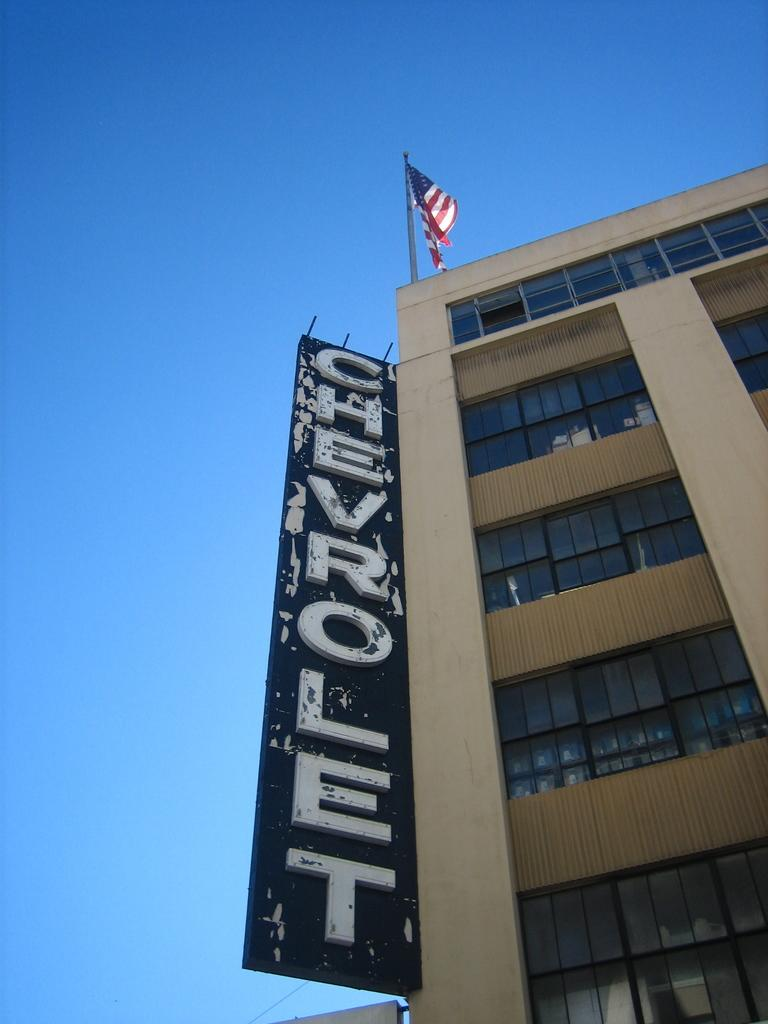What type of structure is present in the image? There is a building in the image. What feature can be seen on the building? The building has windows. Is there any additional information about the building? Yes, there is a board and a flag on the building. What is the opinion of the dime about the building in the image? There is no dime present in the image, and therefore no opinion can be attributed to it. 